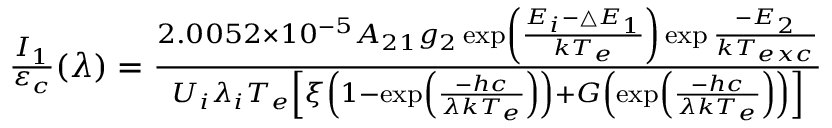Convert formula to latex. <formula><loc_0><loc_0><loc_500><loc_500>\begin{array} { r } { \frac { I _ { 1 } } { \varepsilon _ { c } } ( \lambda ) = \frac { 2 . 0 0 5 2 \times 1 0 ^ { - 5 } A _ { 2 1 } g _ { 2 } \exp \left ( \frac { E _ { i } - \bigtriangleup E _ { 1 } } { k T _ { e } } \right ) \exp \frac { - E _ { 2 } } { k T _ { e x c } } } { U _ { i } \lambda _ { i } T _ { e } \left [ \xi \left ( 1 - \exp \left ( \frac { - h c } { \lambda k T _ { e } } \right ) \right ) + G \left ( \exp \left ( \frac { - h c } { \lambda k T _ { e } } \right ) \right ) \right ] } } \end{array}</formula> 